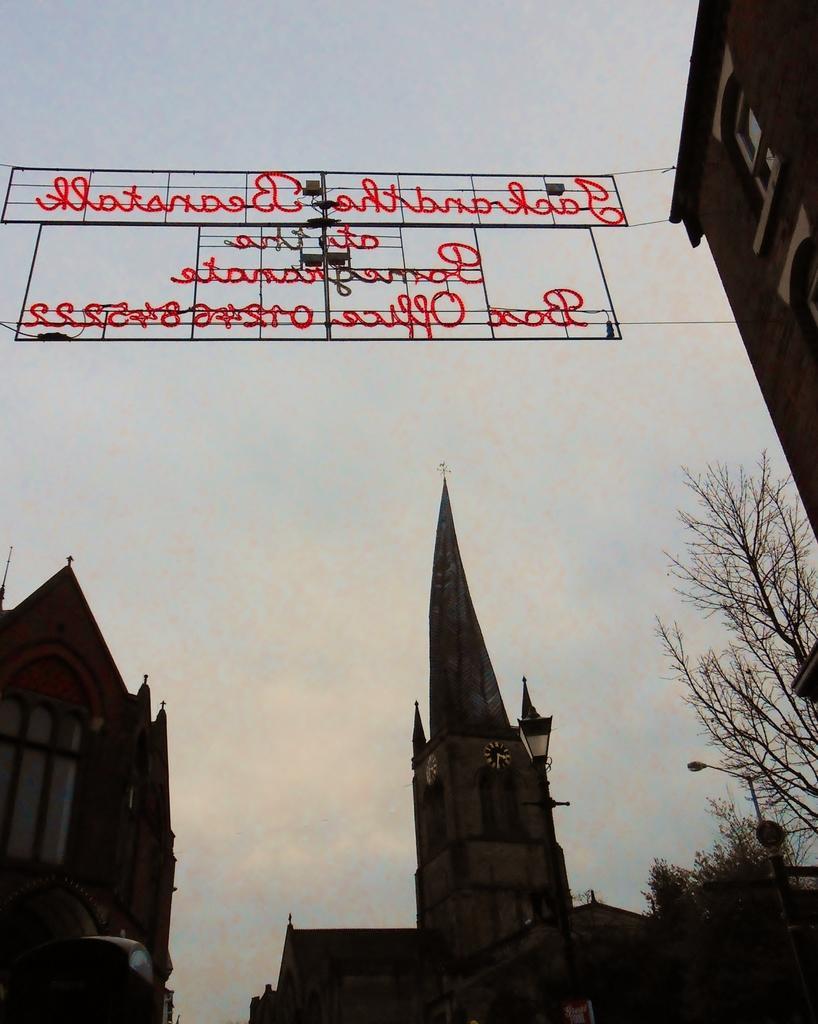Please provide a concise description of this image. At the bottom of the picture, we see the trees, street light, pole, a building and a church. On the right side, we see a building in brown color. In the background, we see the sky. At the top, we see some text written in red color. 